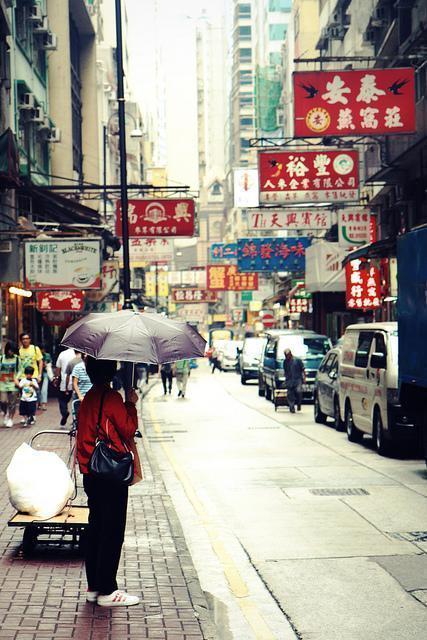Who is the maker of the white shoes?
Pick the correct solution from the four options below to address the question.
Options: Under armour, nike, adidas, new balance. Adidas. 